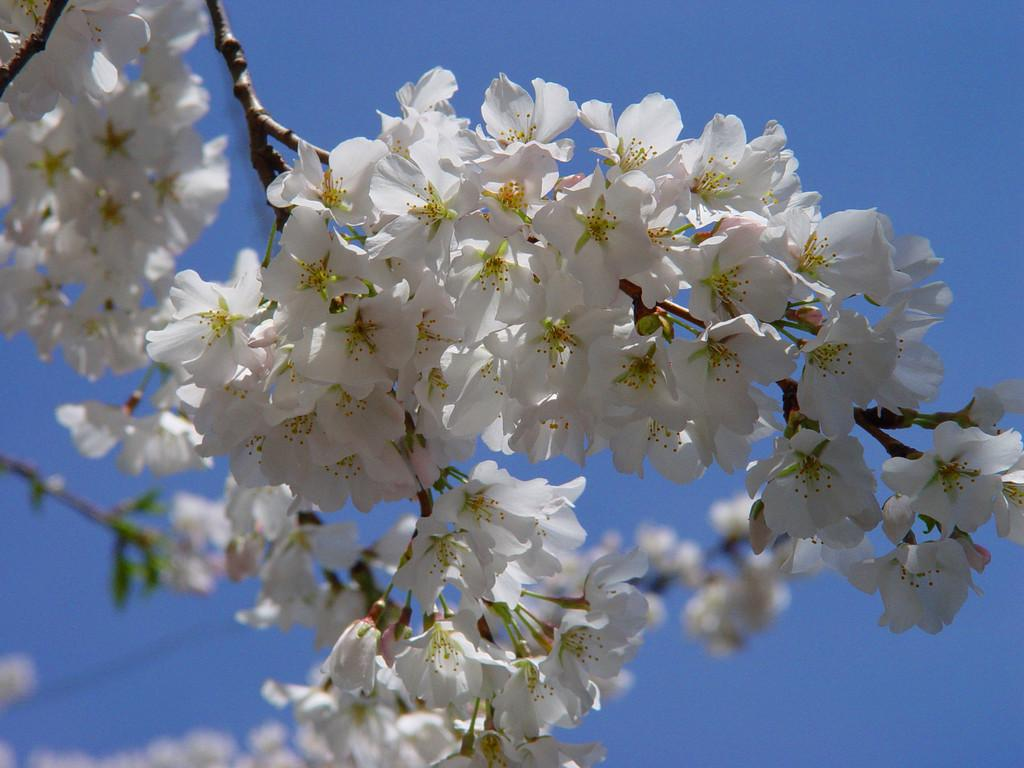What type of flowers can be seen in the image? There are white flowers in the image. Where are the flowers located? The flowers are on the branches of a tree. What color is the object among the flowers? There is a green color object among the flowers. What type of ink is used to draw the ornament on the bedroom wall in the image? There is no ornament on a bedroom wall in the image; it features white flowers on the branches of a tree. 